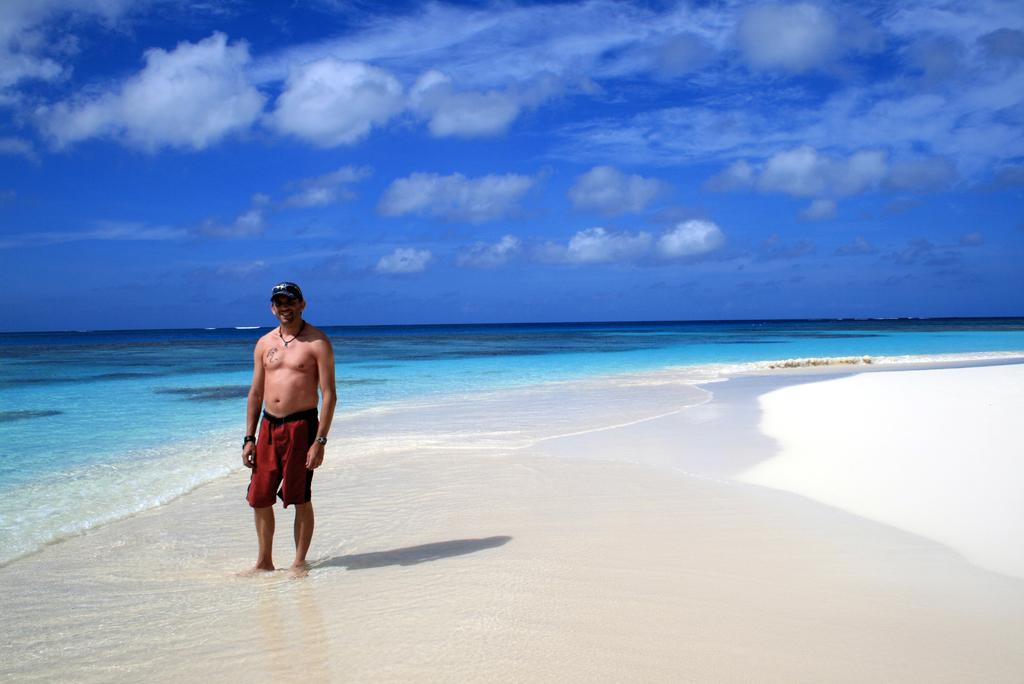Who or what is present in the image? There is a person in the image. Where is the person located? The person is on the beach. What can be seen in the sky in the image? There are clouds in the sky. What type of potato is being served in the lunchroom in the image? There is no lunchroom or potato present in the image; it features a person on the beach with clouds in the sky above. 